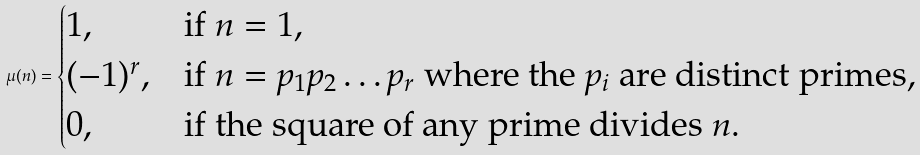<formula> <loc_0><loc_0><loc_500><loc_500>\mu ( n ) = \begin{cases} 1 , & \text {if } n = 1 , \\ ( - 1 ) ^ { r } , & \text {if } n = p _ { 1 } p _ { 2 } \dots p _ { r } \text { where the $p_{i}$ are distinct primes,} \\ 0 , & \text {if the square of any prime divides $n$.} \end{cases}</formula> 